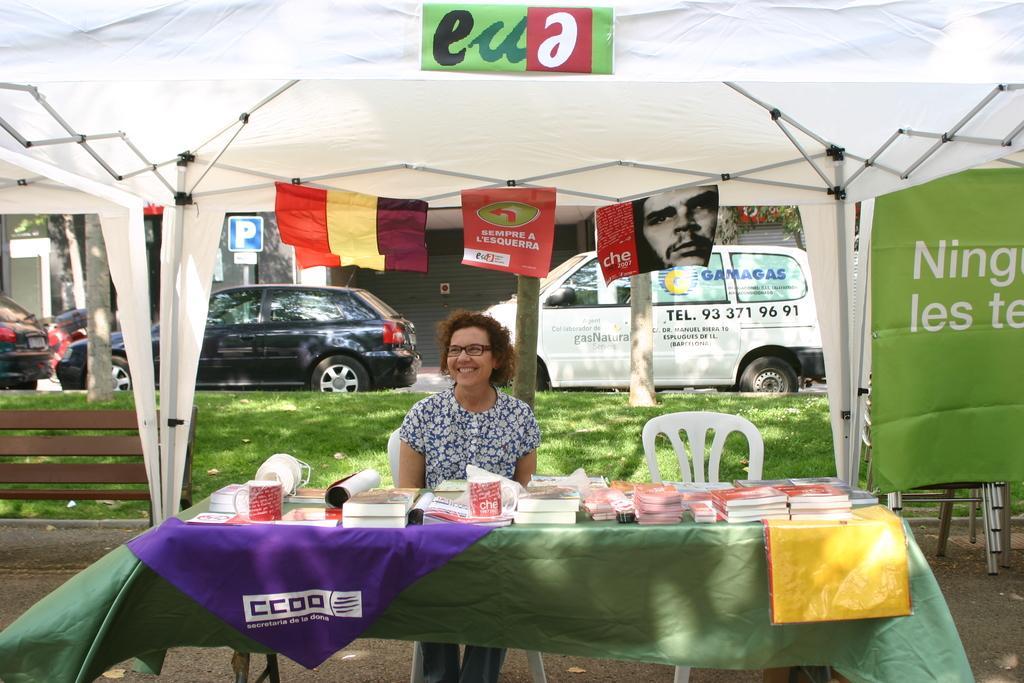Can you describe this image briefly? This image consists of a woman sitting on a chair. In front of her there is a table on which there are many books. In the background, there are cars parked. At the top, there is a tent in white color. 